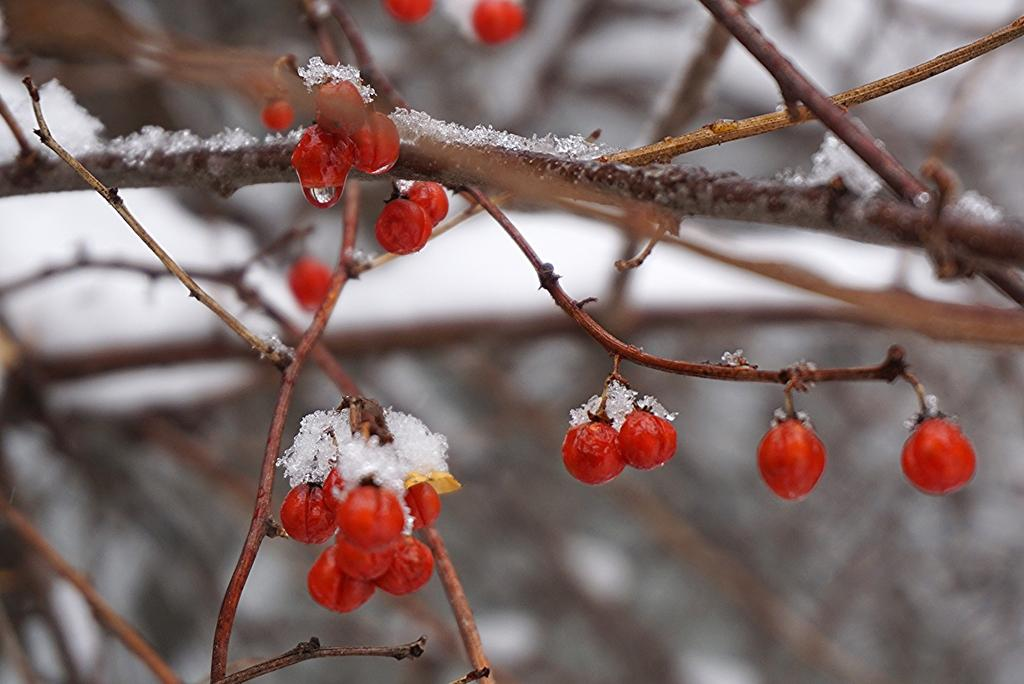What type of food can be seen in the image? There are fruits with stems in the image. What is the condition of the fruits and stems? The fruits and stems have ice on them. Can you describe the background of the image? The background of the image is blurry. What advice does the doctor give to the woman in the image? There is no doctor or woman present in the image; it features fruits with stems and ice. What answer does the woman provide in the image? There is no woman or answer present in the image; it features fruits with stems and ice. 